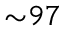Convert formula to latex. <formula><loc_0><loc_0><loc_500><loc_500>{ \sim } 9 7 \</formula> 